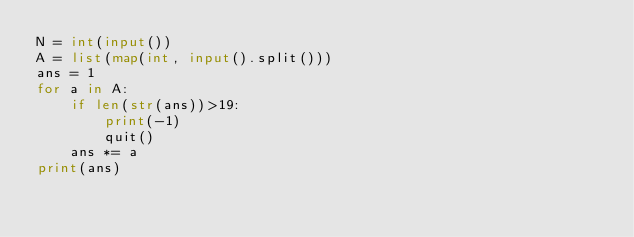Convert code to text. <code><loc_0><loc_0><loc_500><loc_500><_Python_>N = int(input())
A = list(map(int, input().split()))
ans = 1
for a in A:
    if len(str(ans))>19:
        print(-1)
        quit()
    ans *= a
print(ans)</code> 